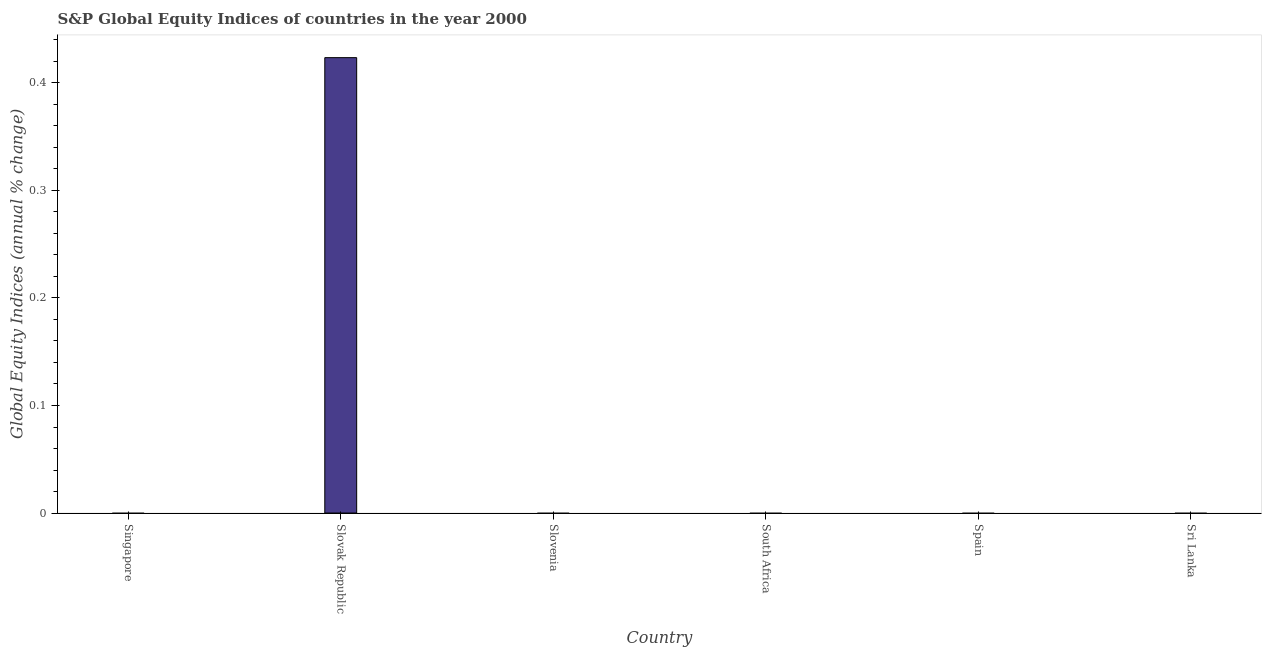What is the title of the graph?
Give a very brief answer. S&P Global Equity Indices of countries in the year 2000. What is the label or title of the X-axis?
Provide a short and direct response. Country. What is the label or title of the Y-axis?
Offer a very short reply. Global Equity Indices (annual % change). Across all countries, what is the maximum s&p global equity indices?
Offer a very short reply. 0.42. In which country was the s&p global equity indices maximum?
Ensure brevity in your answer.  Slovak Republic. What is the sum of the s&p global equity indices?
Provide a succinct answer. 0.42. What is the average s&p global equity indices per country?
Ensure brevity in your answer.  0.07. What is the median s&p global equity indices?
Make the answer very short. 0. In how many countries, is the s&p global equity indices greater than 0.24 %?
Your answer should be compact. 1. What is the difference between the highest and the lowest s&p global equity indices?
Offer a very short reply. 0.42. Are the values on the major ticks of Y-axis written in scientific E-notation?
Offer a terse response. No. What is the Global Equity Indices (annual % change) of Slovak Republic?
Offer a terse response. 0.42. What is the Global Equity Indices (annual % change) in Slovenia?
Give a very brief answer. 0. What is the Global Equity Indices (annual % change) in South Africa?
Your answer should be very brief. 0. What is the Global Equity Indices (annual % change) of Sri Lanka?
Make the answer very short. 0. 